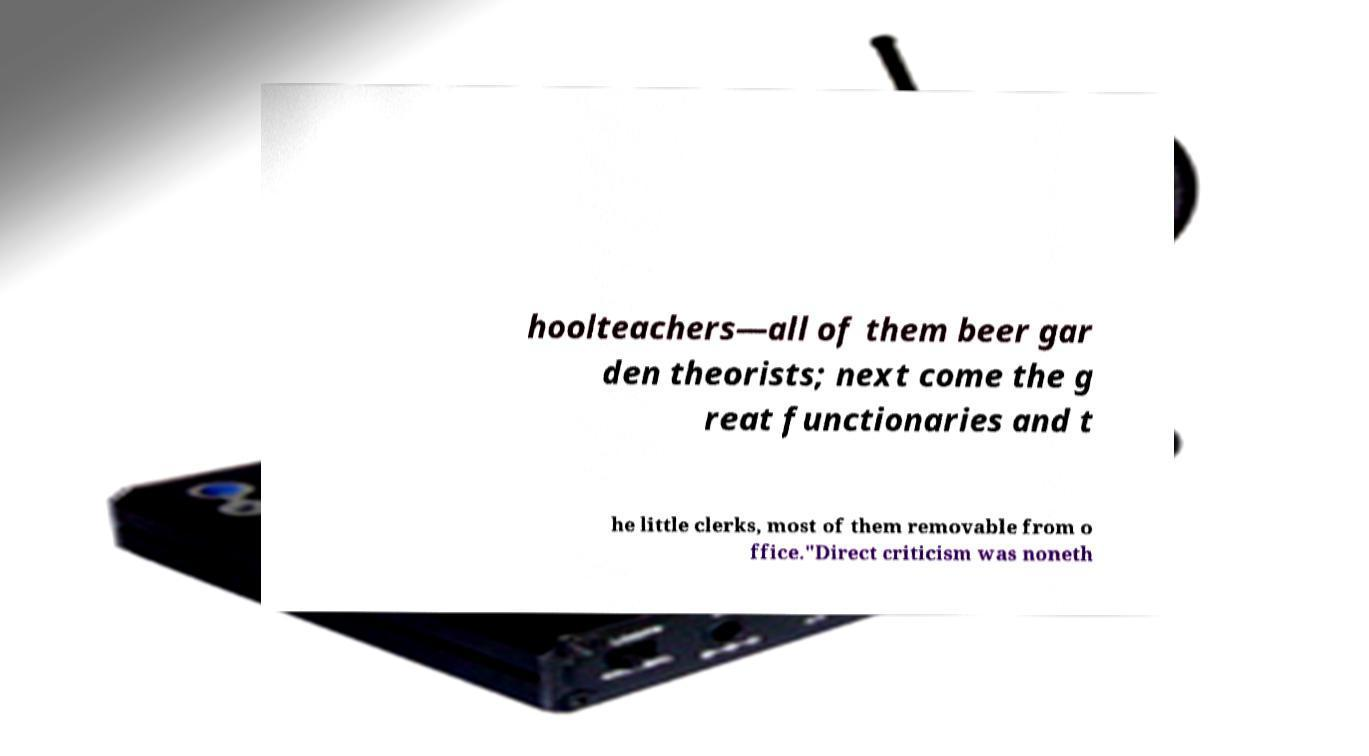Can you read and provide the text displayed in the image?This photo seems to have some interesting text. Can you extract and type it out for me? hoolteachers—all of them beer gar den theorists; next come the g reat functionaries and t he little clerks, most of them removable from o ffice."Direct criticism was noneth 